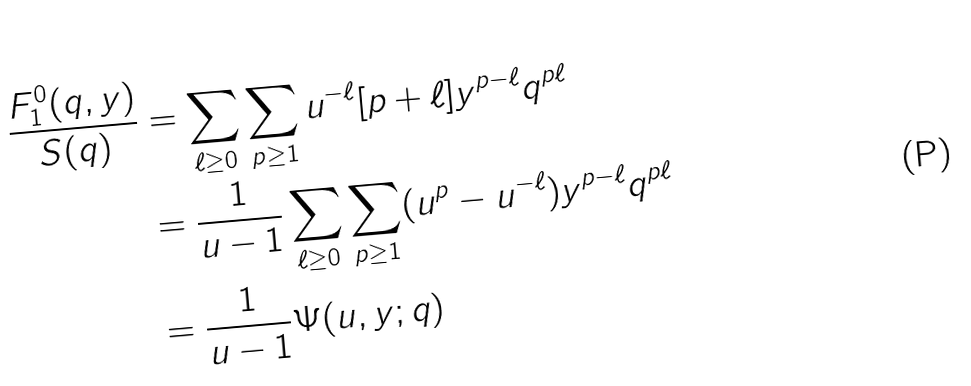Convert formula to latex. <formula><loc_0><loc_0><loc_500><loc_500>\frac { F ^ { 0 } _ { 1 } ( q , y ) } { S ( q ) } & = \sum _ { \ell \geq 0 } \sum _ { p \geq 1 } u ^ { - \ell } [ p + \ell ] y ^ { p - \ell } q ^ { p \ell } \\ & = \frac { 1 } { u - 1 } \sum _ { \ell \geq 0 } \sum _ { p \geq 1 } ( u ^ { p } - u ^ { - \ell } ) y ^ { p - \ell } q ^ { p \ell } \\ & = \frac { 1 } { u - 1 } \Psi ( u , y ; q ) \\</formula> 